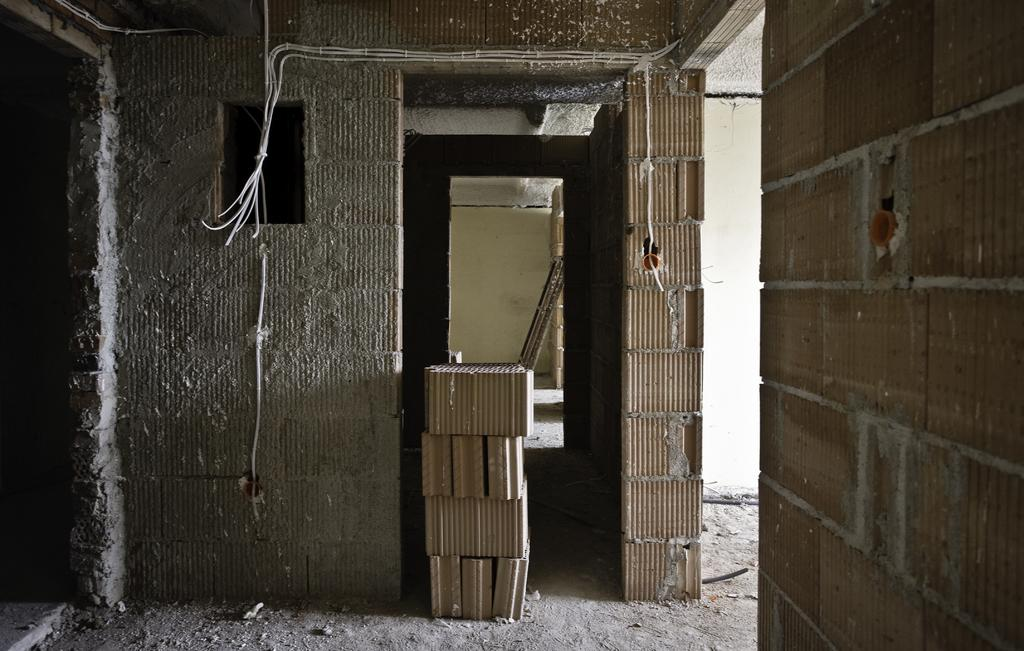What type of flooring is near the wall in the image? There are tiles near the wall in the image. What structure can be seen in the image? There is a gate in the image. What type of wall is on the right side of the image? There is a brick wall on the right side of the image. What book is the person reading in the image? There is no person or book present in the image. What type of form is being filled out in the image? There is no form or activity of filling out forms present in the image. 